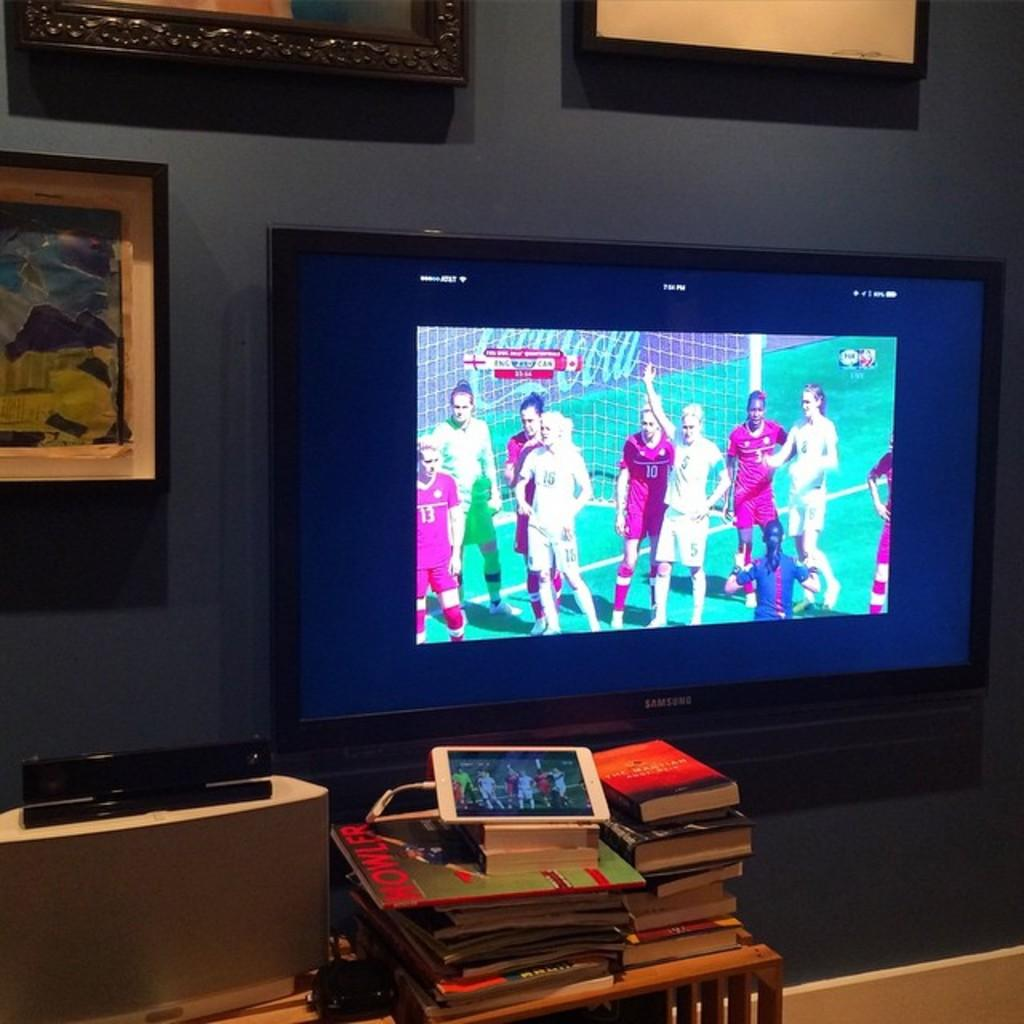What electronic device is visible in the image? There is a TV in the image. What is happening on the TV screen? There are people standing on the TV screen. What items can be seen besides the TV? There are books, a table, a mobile, a wall, and a photo frame in the image. What type of society is depicted in the photo frame in the image? There is no society depicted in the photo frame in the image; it is a separate item from the TV screen. 